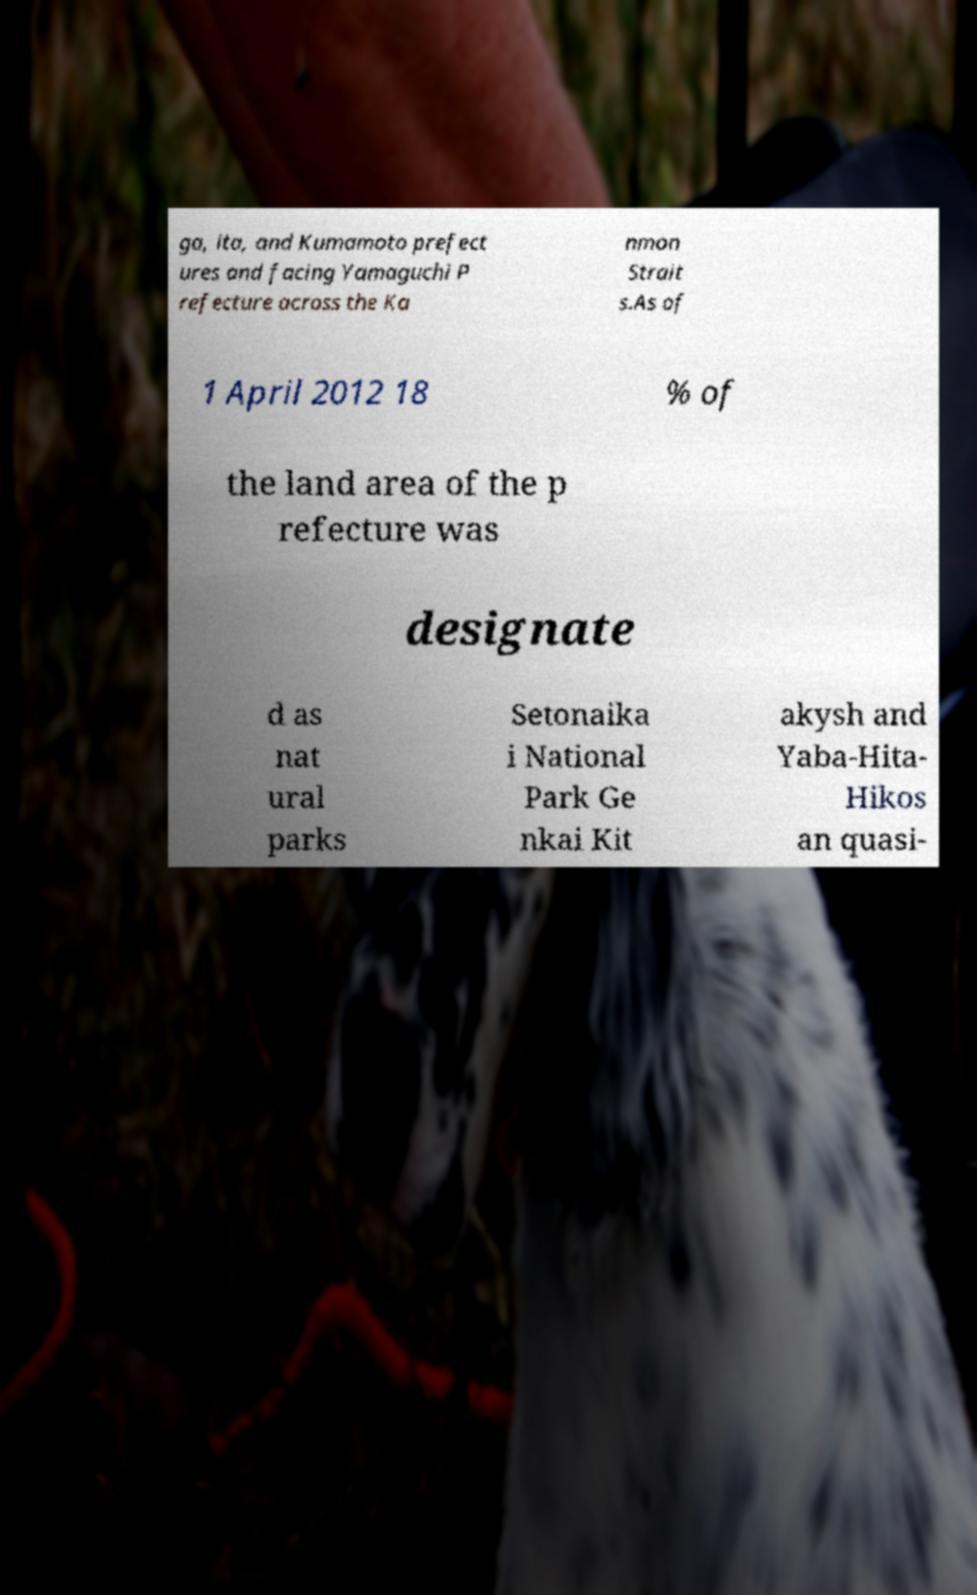What messages or text are displayed in this image? I need them in a readable, typed format. ga, ita, and Kumamoto prefect ures and facing Yamaguchi P refecture across the Ka nmon Strait s.As of 1 April 2012 18 % of the land area of the p refecture was designate d as nat ural parks Setonaika i National Park Ge nkai Kit akysh and Yaba-Hita- Hikos an quasi- 